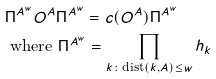<formula> <loc_0><loc_0><loc_500><loc_500>& \Pi ^ { A ^ { w } } O ^ { A } \Pi ^ { A ^ { w } } = c ( O ^ { A } ) \Pi ^ { A ^ { w } } \\ & \text { where } \Pi ^ { A ^ { w } } = \prod _ { k \colon \text {dist} ( k , A ) \leq w } h _ { k }</formula> 